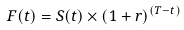<formula> <loc_0><loc_0><loc_500><loc_500>F ( t ) = S ( t ) \times ( 1 + r ) ^ { ( T - t ) }</formula> 